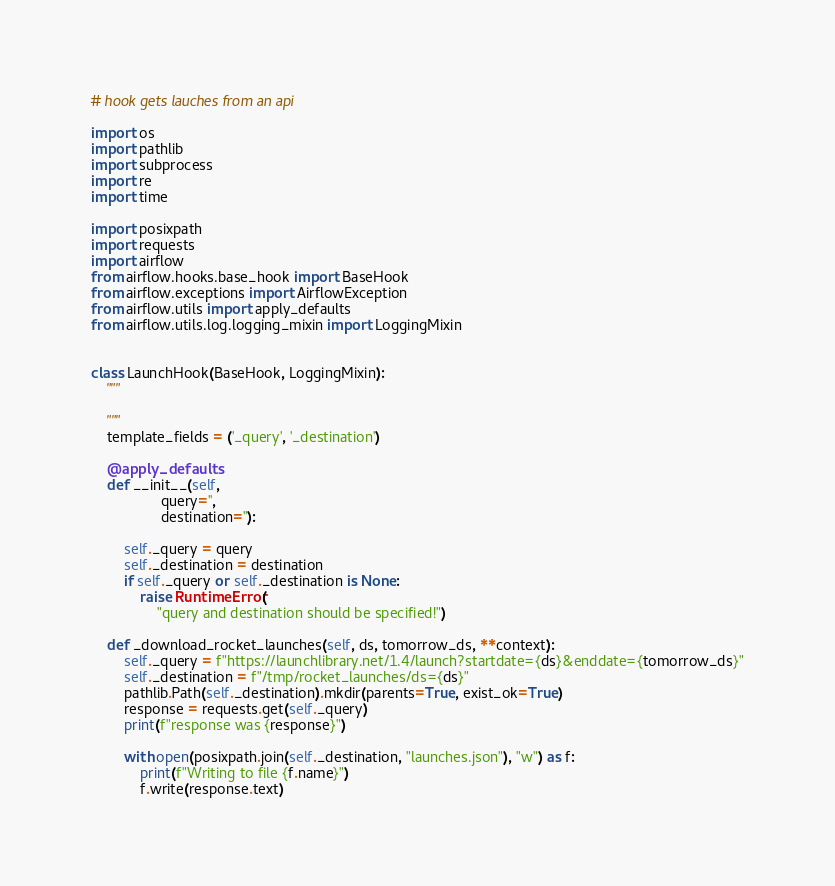Convert code to text. <code><loc_0><loc_0><loc_500><loc_500><_Python_># hook gets lauches from an api

import os
import pathlib
import subprocess
import re
import time

import posixpath
import requests
import airflow
from airflow.hooks.base_hook import BaseHook
from airflow.exceptions import AirflowException
from airflow.utils import apply_defaults
from airflow.utils.log.logging_mixin import LoggingMixin


class LaunchHook(BaseHook, LoggingMixin):
    """

    """
    template_fields = ('_query', '_destination')

    @apply_defaults
    def __init__(self,
                 query='',
                 destination=''):

        self._query = query
        self._destination = destination
        if self._query or self._destination is None:
            raise RuntimeError(
                "query and destination should be specified!")

    def _download_rocket_launches(self, ds, tomorrow_ds, **context):
        self._query = f"https://launchlibrary.net/1.4/launch?startdate={ds}&enddate={tomorrow_ds}"
        self._destination = f"/tmp/rocket_launches/ds={ds}"
        pathlib.Path(self._destination).mkdir(parents=True, exist_ok=True)
        response = requests.get(self._query)
        print(f"response was {response}")

        with open(posixpath.join(self._destination, "launches.json"), "w") as f:
            print(f"Writing to file {f.name}")
            f.write(response.text)

</code> 